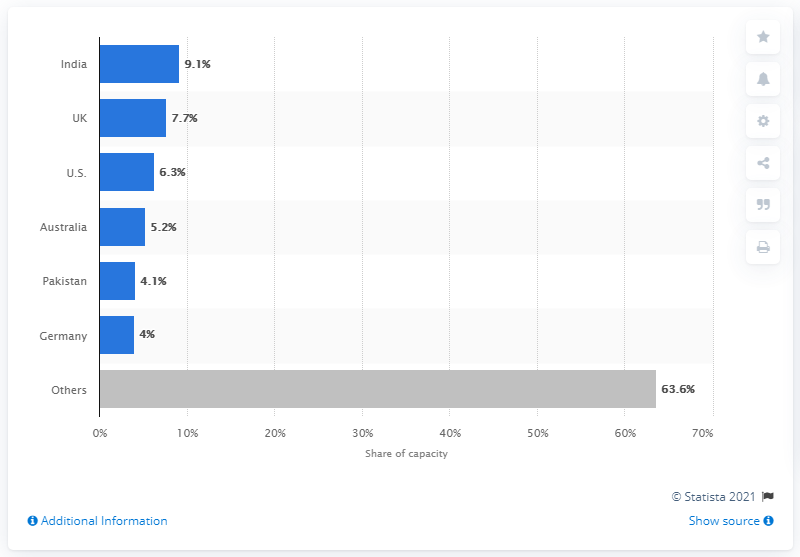Mention a couple of crucial points in this snapshot. India accounted for 9 percent of Emirates' total seat capacity in 2020. 